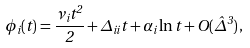<formula> <loc_0><loc_0><loc_500><loc_500>\phi _ { i } ( t ) = \frac { \nu _ { i } t ^ { 2 } } { 2 } + \Delta _ { i i } t + \alpha _ { i } \ln t + O ( \hat { \Delta } ^ { 3 } ) \, ,</formula> 